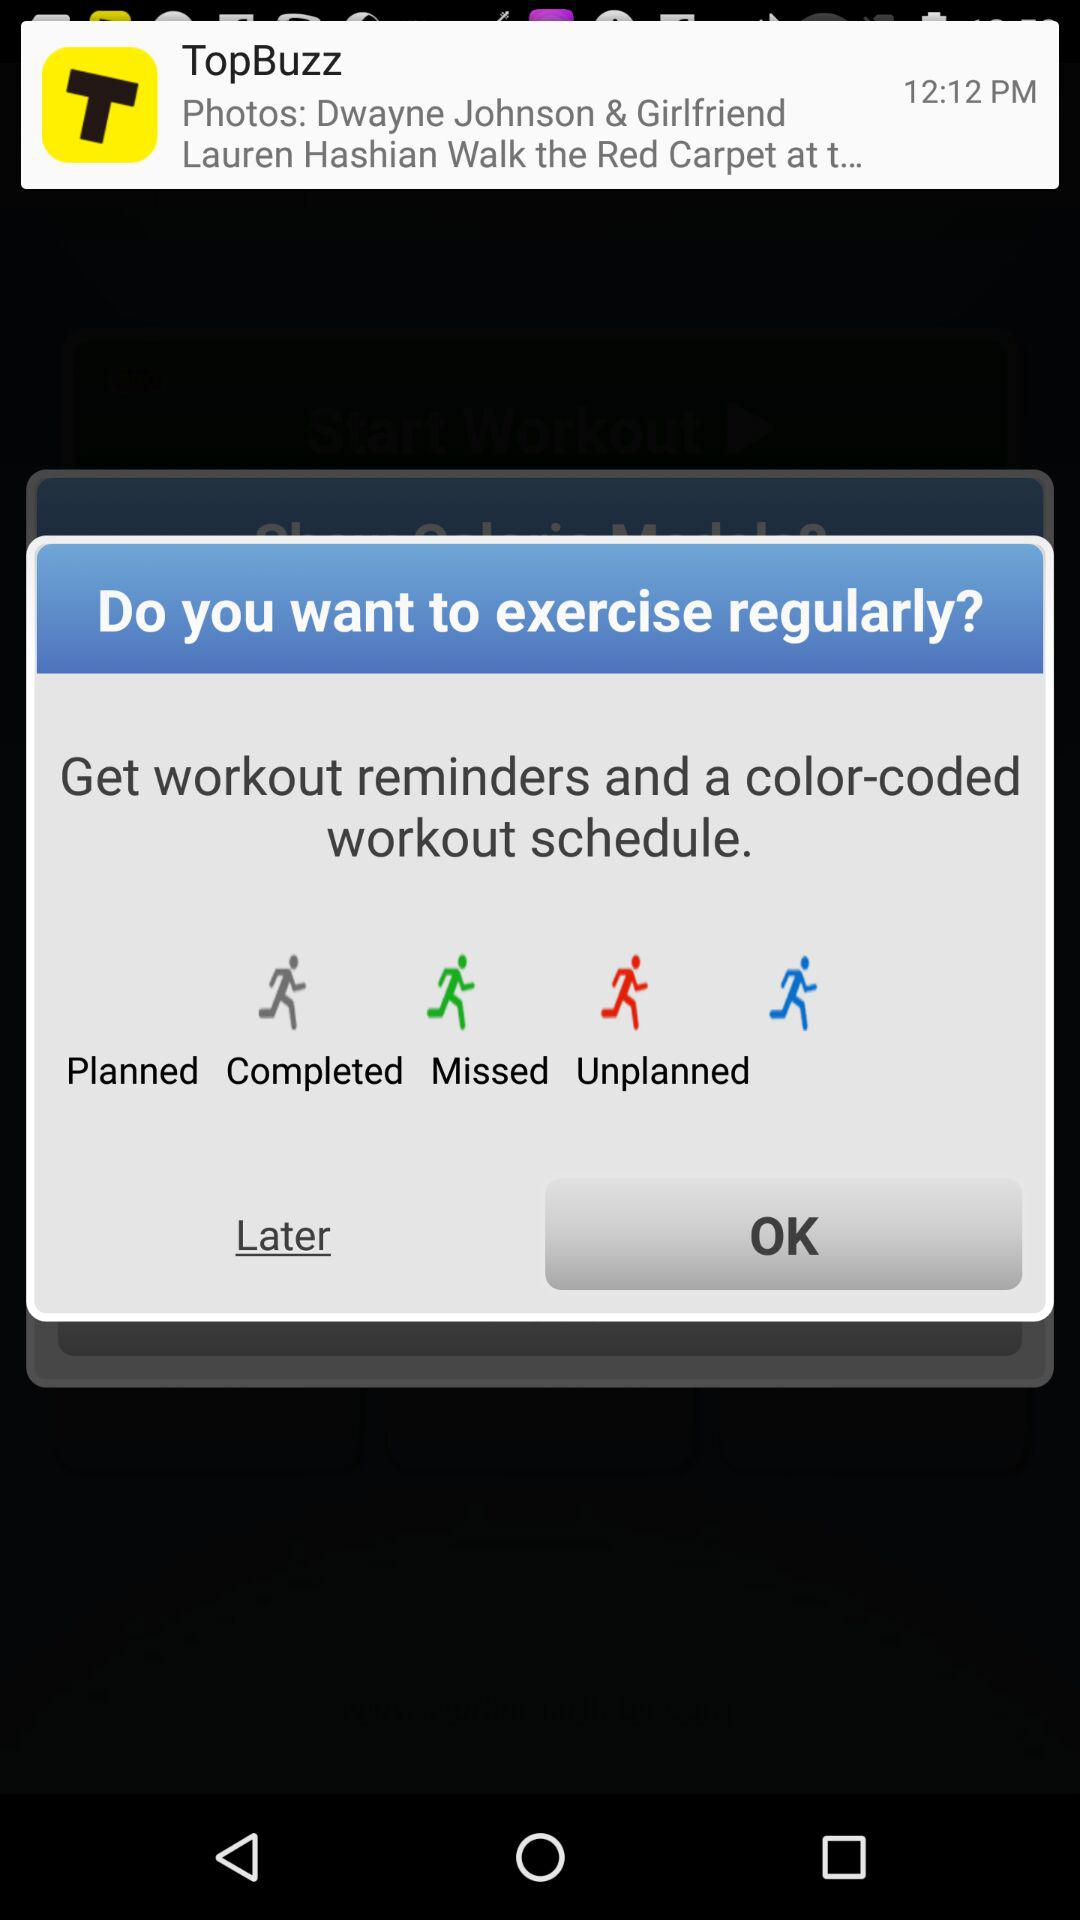How many workout items are there in total?
Answer the question using a single word or phrase. 4 